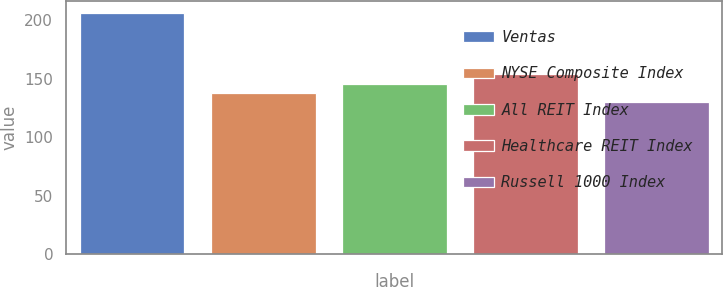<chart> <loc_0><loc_0><loc_500><loc_500><bar_chart><fcel>Ventas<fcel>NYSE Composite Index<fcel>All REIT Index<fcel>Healthcare REIT Index<fcel>Russell 1000 Index<nl><fcel>206<fcel>137.6<fcel>145.2<fcel>154<fcel>130<nl></chart> 